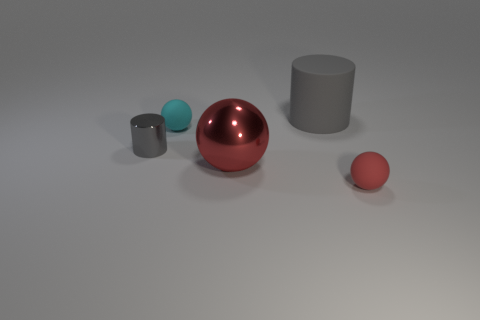Add 1 matte balls. How many objects exist? 6 Subtract all cylinders. How many objects are left? 3 Add 1 gray matte cylinders. How many gray matte cylinders exist? 2 Subtract 0 red blocks. How many objects are left? 5 Subtract all big red cubes. Subtract all red matte spheres. How many objects are left? 4 Add 5 small spheres. How many small spheres are left? 7 